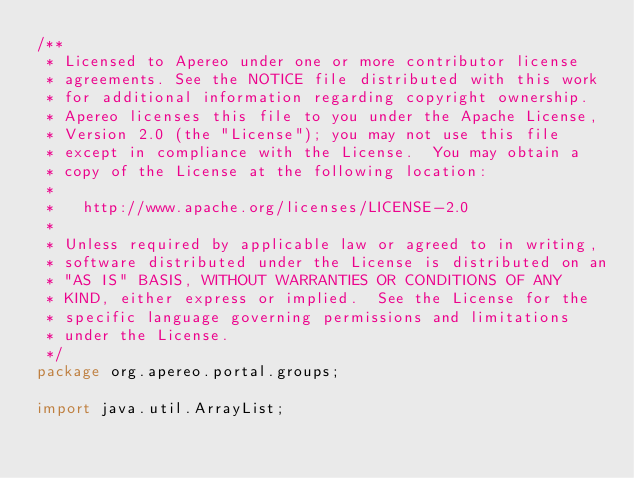<code> <loc_0><loc_0><loc_500><loc_500><_Java_>/**
 * Licensed to Apereo under one or more contributor license
 * agreements. See the NOTICE file distributed with this work
 * for additional information regarding copyright ownership.
 * Apereo licenses this file to you under the Apache License,
 * Version 2.0 (the "License"); you may not use this file
 * except in compliance with the License.  You may obtain a
 * copy of the License at the following location:
 *
 *   http://www.apache.org/licenses/LICENSE-2.0
 *
 * Unless required by applicable law or agreed to in writing,
 * software distributed under the License is distributed on an
 * "AS IS" BASIS, WITHOUT WARRANTIES OR CONDITIONS OF ANY
 * KIND, either express or implied.  See the License for the
 * specific language governing permissions and limitations
 * under the License.
 */
package org.apereo.portal.groups;

import java.util.ArrayList;</code> 